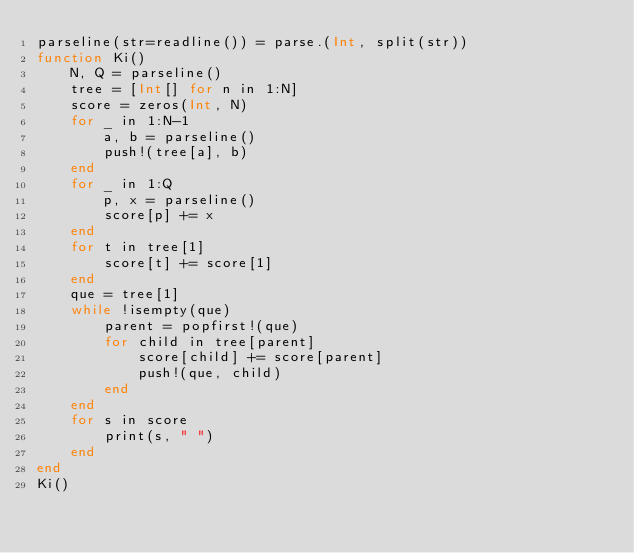<code> <loc_0><loc_0><loc_500><loc_500><_Julia_>parseline(str=readline()) = parse.(Int, split(str))
function Ki()
    N, Q = parseline()
    tree = [Int[] for n in 1:N]
    score = zeros(Int, N)
    for _ in 1:N-1
        a, b = parseline()
        push!(tree[a], b)
    end
    for _ in 1:Q
        p, x = parseline()
        score[p] += x
    end
    for t in tree[1]
        score[t] += score[1]
    end
    que = tree[1]
    while !isempty(que)
        parent = popfirst!(que)
        for child in tree[parent]
            score[child] += score[parent]
            push!(que, child)
        end
    end
    for s in score
        print(s, " ")
    end
end
Ki()</code> 